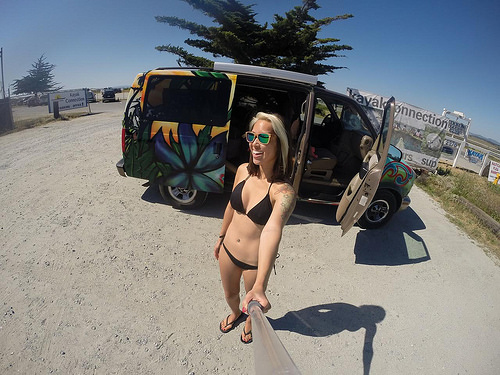<image>
Can you confirm if the shadow is behind the woman? Yes. From this viewpoint, the shadow is positioned behind the woman, with the woman partially or fully occluding the shadow. 